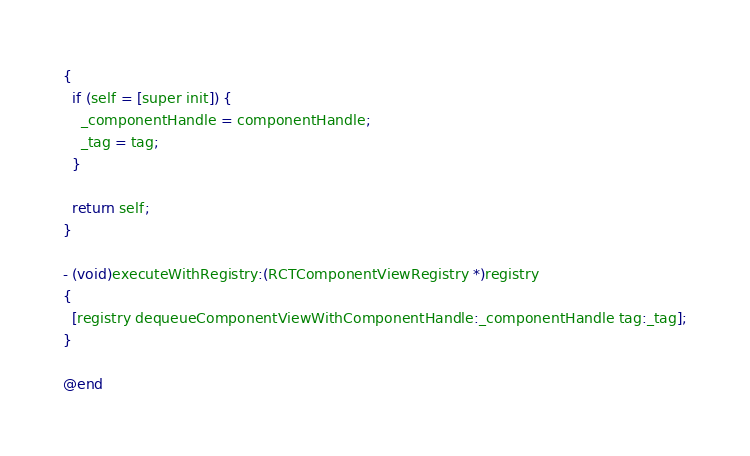<code> <loc_0><loc_0><loc_500><loc_500><_ObjectiveC_>{
  if (self = [super init]) {
    _componentHandle = componentHandle;
    _tag = tag;
  }

  return self;
}

- (void)executeWithRegistry:(RCTComponentViewRegistry *)registry
{
  [registry dequeueComponentViewWithComponentHandle:_componentHandle tag:_tag];
}

@end
</code> 